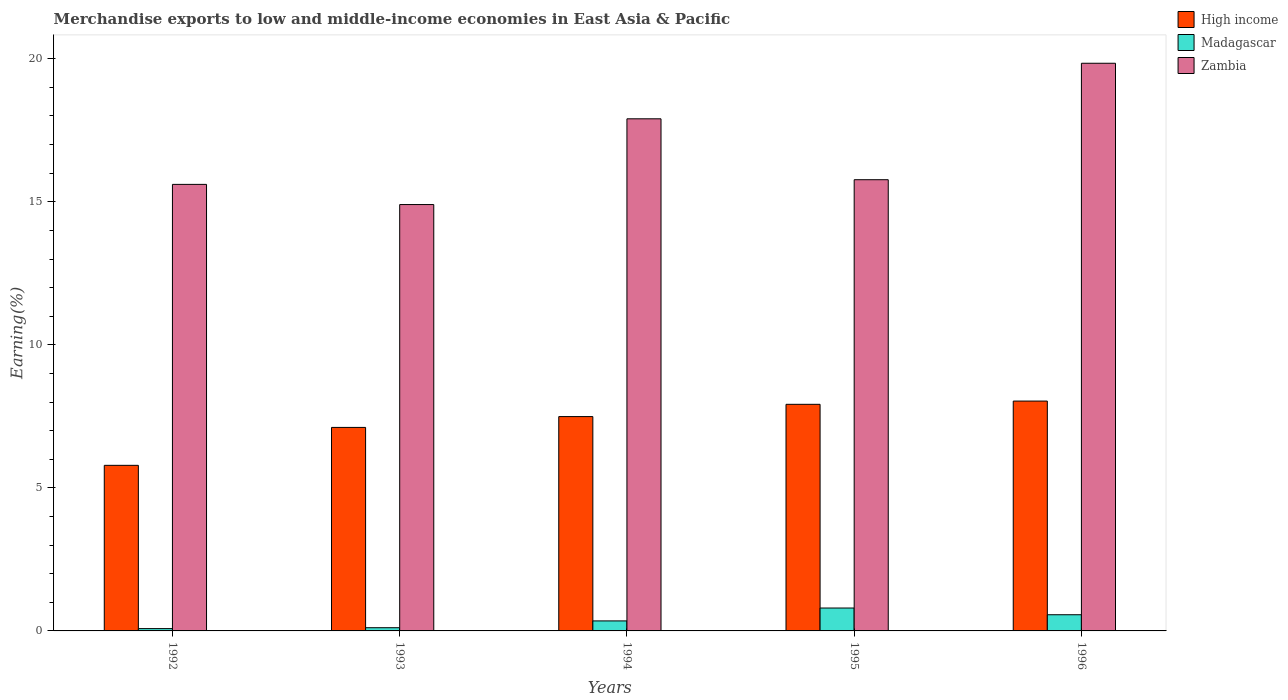How many different coloured bars are there?
Keep it short and to the point. 3. How many groups of bars are there?
Your answer should be very brief. 5. Are the number of bars on each tick of the X-axis equal?
Provide a short and direct response. Yes. How many bars are there on the 1st tick from the right?
Give a very brief answer. 3. What is the label of the 3rd group of bars from the left?
Give a very brief answer. 1994. What is the percentage of amount earned from merchandise exports in High income in 1992?
Make the answer very short. 5.79. Across all years, what is the maximum percentage of amount earned from merchandise exports in Madagascar?
Offer a very short reply. 0.8. Across all years, what is the minimum percentage of amount earned from merchandise exports in Madagascar?
Make the answer very short. 0.08. In which year was the percentage of amount earned from merchandise exports in Zambia minimum?
Provide a short and direct response. 1993. What is the total percentage of amount earned from merchandise exports in Zambia in the graph?
Your response must be concise. 84.03. What is the difference between the percentage of amount earned from merchandise exports in Zambia in 1995 and that in 1996?
Your answer should be very brief. -4.07. What is the difference between the percentage of amount earned from merchandise exports in Zambia in 1996 and the percentage of amount earned from merchandise exports in Madagascar in 1995?
Make the answer very short. 19.04. What is the average percentage of amount earned from merchandise exports in High income per year?
Make the answer very short. 7.27. In the year 1992, what is the difference between the percentage of amount earned from merchandise exports in Zambia and percentage of amount earned from merchandise exports in High income?
Make the answer very short. 9.82. What is the ratio of the percentage of amount earned from merchandise exports in Madagascar in 1993 to that in 1994?
Your response must be concise. 0.32. Is the difference between the percentage of amount earned from merchandise exports in Zambia in 1993 and 1994 greater than the difference between the percentage of amount earned from merchandise exports in High income in 1993 and 1994?
Keep it short and to the point. No. What is the difference between the highest and the second highest percentage of amount earned from merchandise exports in Zambia?
Give a very brief answer. 1.94. What is the difference between the highest and the lowest percentage of amount earned from merchandise exports in Zambia?
Provide a short and direct response. 4.94. In how many years, is the percentage of amount earned from merchandise exports in Zambia greater than the average percentage of amount earned from merchandise exports in Zambia taken over all years?
Offer a terse response. 2. What does the 3rd bar from the left in 1995 represents?
Your answer should be very brief. Zambia. What does the 3rd bar from the right in 1996 represents?
Your answer should be compact. High income. How many bars are there?
Ensure brevity in your answer.  15. How many years are there in the graph?
Offer a terse response. 5. What is the difference between two consecutive major ticks on the Y-axis?
Make the answer very short. 5. Are the values on the major ticks of Y-axis written in scientific E-notation?
Ensure brevity in your answer.  No. Does the graph contain any zero values?
Your answer should be very brief. No. Does the graph contain grids?
Ensure brevity in your answer.  No. Where does the legend appear in the graph?
Make the answer very short. Top right. What is the title of the graph?
Your response must be concise. Merchandise exports to low and middle-income economies in East Asia & Pacific. Does "Peru" appear as one of the legend labels in the graph?
Keep it short and to the point. No. What is the label or title of the X-axis?
Your response must be concise. Years. What is the label or title of the Y-axis?
Ensure brevity in your answer.  Earning(%). What is the Earning(%) in High income in 1992?
Provide a succinct answer. 5.79. What is the Earning(%) of Madagascar in 1992?
Your answer should be very brief. 0.08. What is the Earning(%) of Zambia in 1992?
Offer a very short reply. 15.61. What is the Earning(%) in High income in 1993?
Provide a succinct answer. 7.11. What is the Earning(%) of Madagascar in 1993?
Offer a very short reply. 0.11. What is the Earning(%) of Zambia in 1993?
Your answer should be very brief. 14.9. What is the Earning(%) in High income in 1994?
Ensure brevity in your answer.  7.49. What is the Earning(%) in Madagascar in 1994?
Your answer should be compact. 0.35. What is the Earning(%) of Zambia in 1994?
Your response must be concise. 17.9. What is the Earning(%) in High income in 1995?
Your response must be concise. 7.92. What is the Earning(%) of Madagascar in 1995?
Offer a terse response. 0.8. What is the Earning(%) of Zambia in 1995?
Give a very brief answer. 15.77. What is the Earning(%) in High income in 1996?
Your answer should be compact. 8.03. What is the Earning(%) in Madagascar in 1996?
Give a very brief answer. 0.57. What is the Earning(%) in Zambia in 1996?
Provide a short and direct response. 19.84. Across all years, what is the maximum Earning(%) in High income?
Provide a succinct answer. 8.03. Across all years, what is the maximum Earning(%) of Madagascar?
Provide a succinct answer. 0.8. Across all years, what is the maximum Earning(%) in Zambia?
Keep it short and to the point. 19.84. Across all years, what is the minimum Earning(%) of High income?
Your answer should be compact. 5.79. Across all years, what is the minimum Earning(%) in Madagascar?
Provide a short and direct response. 0.08. Across all years, what is the minimum Earning(%) of Zambia?
Provide a short and direct response. 14.9. What is the total Earning(%) in High income in the graph?
Give a very brief answer. 36.35. What is the total Earning(%) in Madagascar in the graph?
Make the answer very short. 1.91. What is the total Earning(%) in Zambia in the graph?
Your answer should be compact. 84.03. What is the difference between the Earning(%) of High income in 1992 and that in 1993?
Keep it short and to the point. -1.33. What is the difference between the Earning(%) of Madagascar in 1992 and that in 1993?
Keep it short and to the point. -0.03. What is the difference between the Earning(%) in Zambia in 1992 and that in 1993?
Give a very brief answer. 0.71. What is the difference between the Earning(%) of High income in 1992 and that in 1994?
Your answer should be very brief. -1.7. What is the difference between the Earning(%) in Madagascar in 1992 and that in 1994?
Give a very brief answer. -0.27. What is the difference between the Earning(%) of Zambia in 1992 and that in 1994?
Your answer should be very brief. -2.29. What is the difference between the Earning(%) of High income in 1992 and that in 1995?
Keep it short and to the point. -2.13. What is the difference between the Earning(%) of Madagascar in 1992 and that in 1995?
Your response must be concise. -0.72. What is the difference between the Earning(%) in Zambia in 1992 and that in 1995?
Offer a terse response. -0.16. What is the difference between the Earning(%) of High income in 1992 and that in 1996?
Ensure brevity in your answer.  -2.25. What is the difference between the Earning(%) in Madagascar in 1992 and that in 1996?
Offer a very short reply. -0.48. What is the difference between the Earning(%) of Zambia in 1992 and that in 1996?
Your response must be concise. -4.23. What is the difference between the Earning(%) in High income in 1993 and that in 1994?
Make the answer very short. -0.38. What is the difference between the Earning(%) in Madagascar in 1993 and that in 1994?
Provide a succinct answer. -0.24. What is the difference between the Earning(%) in Zambia in 1993 and that in 1994?
Ensure brevity in your answer.  -3. What is the difference between the Earning(%) of High income in 1993 and that in 1995?
Make the answer very short. -0.81. What is the difference between the Earning(%) of Madagascar in 1993 and that in 1995?
Keep it short and to the point. -0.69. What is the difference between the Earning(%) of Zambia in 1993 and that in 1995?
Give a very brief answer. -0.87. What is the difference between the Earning(%) of High income in 1993 and that in 1996?
Ensure brevity in your answer.  -0.92. What is the difference between the Earning(%) in Madagascar in 1993 and that in 1996?
Give a very brief answer. -0.45. What is the difference between the Earning(%) of Zambia in 1993 and that in 1996?
Provide a short and direct response. -4.94. What is the difference between the Earning(%) of High income in 1994 and that in 1995?
Your answer should be very brief. -0.43. What is the difference between the Earning(%) of Madagascar in 1994 and that in 1995?
Make the answer very short. -0.45. What is the difference between the Earning(%) of Zambia in 1994 and that in 1995?
Ensure brevity in your answer.  2.13. What is the difference between the Earning(%) of High income in 1994 and that in 1996?
Your answer should be very brief. -0.54. What is the difference between the Earning(%) in Madagascar in 1994 and that in 1996?
Your answer should be very brief. -0.22. What is the difference between the Earning(%) of Zambia in 1994 and that in 1996?
Make the answer very short. -1.94. What is the difference between the Earning(%) of High income in 1995 and that in 1996?
Your answer should be very brief. -0.11. What is the difference between the Earning(%) of Madagascar in 1995 and that in 1996?
Offer a very short reply. 0.23. What is the difference between the Earning(%) in Zambia in 1995 and that in 1996?
Keep it short and to the point. -4.07. What is the difference between the Earning(%) in High income in 1992 and the Earning(%) in Madagascar in 1993?
Provide a succinct answer. 5.68. What is the difference between the Earning(%) of High income in 1992 and the Earning(%) of Zambia in 1993?
Your response must be concise. -9.12. What is the difference between the Earning(%) of Madagascar in 1992 and the Earning(%) of Zambia in 1993?
Your response must be concise. -14.82. What is the difference between the Earning(%) in High income in 1992 and the Earning(%) in Madagascar in 1994?
Offer a very short reply. 5.44. What is the difference between the Earning(%) of High income in 1992 and the Earning(%) of Zambia in 1994?
Ensure brevity in your answer.  -12.11. What is the difference between the Earning(%) in Madagascar in 1992 and the Earning(%) in Zambia in 1994?
Your response must be concise. -17.82. What is the difference between the Earning(%) in High income in 1992 and the Earning(%) in Madagascar in 1995?
Ensure brevity in your answer.  4.99. What is the difference between the Earning(%) in High income in 1992 and the Earning(%) in Zambia in 1995?
Your answer should be very brief. -9.98. What is the difference between the Earning(%) in Madagascar in 1992 and the Earning(%) in Zambia in 1995?
Your response must be concise. -15.69. What is the difference between the Earning(%) in High income in 1992 and the Earning(%) in Madagascar in 1996?
Your response must be concise. 5.22. What is the difference between the Earning(%) in High income in 1992 and the Earning(%) in Zambia in 1996?
Your answer should be compact. -14.05. What is the difference between the Earning(%) of Madagascar in 1992 and the Earning(%) of Zambia in 1996?
Offer a very short reply. -19.76. What is the difference between the Earning(%) in High income in 1993 and the Earning(%) in Madagascar in 1994?
Make the answer very short. 6.76. What is the difference between the Earning(%) in High income in 1993 and the Earning(%) in Zambia in 1994?
Offer a very short reply. -10.79. What is the difference between the Earning(%) in Madagascar in 1993 and the Earning(%) in Zambia in 1994?
Offer a very short reply. -17.79. What is the difference between the Earning(%) of High income in 1993 and the Earning(%) of Madagascar in 1995?
Offer a very short reply. 6.31. What is the difference between the Earning(%) in High income in 1993 and the Earning(%) in Zambia in 1995?
Your answer should be compact. -8.66. What is the difference between the Earning(%) in Madagascar in 1993 and the Earning(%) in Zambia in 1995?
Offer a terse response. -15.66. What is the difference between the Earning(%) of High income in 1993 and the Earning(%) of Madagascar in 1996?
Provide a short and direct response. 6.55. What is the difference between the Earning(%) in High income in 1993 and the Earning(%) in Zambia in 1996?
Your answer should be compact. -12.73. What is the difference between the Earning(%) of Madagascar in 1993 and the Earning(%) of Zambia in 1996?
Your answer should be compact. -19.73. What is the difference between the Earning(%) in High income in 1994 and the Earning(%) in Madagascar in 1995?
Keep it short and to the point. 6.69. What is the difference between the Earning(%) in High income in 1994 and the Earning(%) in Zambia in 1995?
Keep it short and to the point. -8.28. What is the difference between the Earning(%) in Madagascar in 1994 and the Earning(%) in Zambia in 1995?
Your response must be concise. -15.42. What is the difference between the Earning(%) in High income in 1994 and the Earning(%) in Madagascar in 1996?
Provide a short and direct response. 6.93. What is the difference between the Earning(%) in High income in 1994 and the Earning(%) in Zambia in 1996?
Ensure brevity in your answer.  -12.35. What is the difference between the Earning(%) of Madagascar in 1994 and the Earning(%) of Zambia in 1996?
Ensure brevity in your answer.  -19.49. What is the difference between the Earning(%) of High income in 1995 and the Earning(%) of Madagascar in 1996?
Keep it short and to the point. 7.36. What is the difference between the Earning(%) in High income in 1995 and the Earning(%) in Zambia in 1996?
Offer a very short reply. -11.92. What is the difference between the Earning(%) in Madagascar in 1995 and the Earning(%) in Zambia in 1996?
Make the answer very short. -19.04. What is the average Earning(%) in High income per year?
Your answer should be compact. 7.27. What is the average Earning(%) in Madagascar per year?
Your response must be concise. 0.38. What is the average Earning(%) of Zambia per year?
Your response must be concise. 16.81. In the year 1992, what is the difference between the Earning(%) of High income and Earning(%) of Madagascar?
Offer a terse response. 5.71. In the year 1992, what is the difference between the Earning(%) of High income and Earning(%) of Zambia?
Your answer should be compact. -9.82. In the year 1992, what is the difference between the Earning(%) in Madagascar and Earning(%) in Zambia?
Your answer should be very brief. -15.53. In the year 1993, what is the difference between the Earning(%) of High income and Earning(%) of Madagascar?
Your response must be concise. 7. In the year 1993, what is the difference between the Earning(%) of High income and Earning(%) of Zambia?
Ensure brevity in your answer.  -7.79. In the year 1993, what is the difference between the Earning(%) of Madagascar and Earning(%) of Zambia?
Provide a short and direct response. -14.79. In the year 1994, what is the difference between the Earning(%) in High income and Earning(%) in Madagascar?
Your answer should be compact. 7.14. In the year 1994, what is the difference between the Earning(%) in High income and Earning(%) in Zambia?
Make the answer very short. -10.41. In the year 1994, what is the difference between the Earning(%) in Madagascar and Earning(%) in Zambia?
Keep it short and to the point. -17.55. In the year 1995, what is the difference between the Earning(%) in High income and Earning(%) in Madagascar?
Provide a short and direct response. 7.12. In the year 1995, what is the difference between the Earning(%) in High income and Earning(%) in Zambia?
Make the answer very short. -7.85. In the year 1995, what is the difference between the Earning(%) of Madagascar and Earning(%) of Zambia?
Keep it short and to the point. -14.97. In the year 1996, what is the difference between the Earning(%) of High income and Earning(%) of Madagascar?
Offer a very short reply. 7.47. In the year 1996, what is the difference between the Earning(%) in High income and Earning(%) in Zambia?
Make the answer very short. -11.81. In the year 1996, what is the difference between the Earning(%) in Madagascar and Earning(%) in Zambia?
Offer a terse response. -19.28. What is the ratio of the Earning(%) of High income in 1992 to that in 1993?
Provide a short and direct response. 0.81. What is the ratio of the Earning(%) of Madagascar in 1992 to that in 1993?
Provide a succinct answer. 0.72. What is the ratio of the Earning(%) of Zambia in 1992 to that in 1993?
Your response must be concise. 1.05. What is the ratio of the Earning(%) of High income in 1992 to that in 1994?
Offer a very short reply. 0.77. What is the ratio of the Earning(%) of Madagascar in 1992 to that in 1994?
Your response must be concise. 0.23. What is the ratio of the Earning(%) of Zambia in 1992 to that in 1994?
Give a very brief answer. 0.87. What is the ratio of the Earning(%) in High income in 1992 to that in 1995?
Keep it short and to the point. 0.73. What is the ratio of the Earning(%) in Madagascar in 1992 to that in 1995?
Offer a very short reply. 0.1. What is the ratio of the Earning(%) of Zambia in 1992 to that in 1995?
Give a very brief answer. 0.99. What is the ratio of the Earning(%) in High income in 1992 to that in 1996?
Keep it short and to the point. 0.72. What is the ratio of the Earning(%) of Madagascar in 1992 to that in 1996?
Offer a very short reply. 0.14. What is the ratio of the Earning(%) in Zambia in 1992 to that in 1996?
Provide a short and direct response. 0.79. What is the ratio of the Earning(%) in High income in 1993 to that in 1994?
Provide a succinct answer. 0.95. What is the ratio of the Earning(%) of Madagascar in 1993 to that in 1994?
Your answer should be very brief. 0.32. What is the ratio of the Earning(%) of Zambia in 1993 to that in 1994?
Give a very brief answer. 0.83. What is the ratio of the Earning(%) in High income in 1993 to that in 1995?
Your answer should be compact. 0.9. What is the ratio of the Earning(%) of Madagascar in 1993 to that in 1995?
Your response must be concise. 0.14. What is the ratio of the Earning(%) of Zambia in 1993 to that in 1995?
Provide a short and direct response. 0.94. What is the ratio of the Earning(%) in High income in 1993 to that in 1996?
Keep it short and to the point. 0.89. What is the ratio of the Earning(%) in Madagascar in 1993 to that in 1996?
Make the answer very short. 0.2. What is the ratio of the Earning(%) of Zambia in 1993 to that in 1996?
Provide a succinct answer. 0.75. What is the ratio of the Earning(%) of High income in 1994 to that in 1995?
Keep it short and to the point. 0.95. What is the ratio of the Earning(%) in Madagascar in 1994 to that in 1995?
Give a very brief answer. 0.44. What is the ratio of the Earning(%) of Zambia in 1994 to that in 1995?
Keep it short and to the point. 1.14. What is the ratio of the Earning(%) of High income in 1994 to that in 1996?
Your answer should be compact. 0.93. What is the ratio of the Earning(%) of Madagascar in 1994 to that in 1996?
Keep it short and to the point. 0.62. What is the ratio of the Earning(%) in Zambia in 1994 to that in 1996?
Make the answer very short. 0.9. What is the ratio of the Earning(%) in High income in 1995 to that in 1996?
Keep it short and to the point. 0.99. What is the ratio of the Earning(%) of Madagascar in 1995 to that in 1996?
Make the answer very short. 1.41. What is the ratio of the Earning(%) in Zambia in 1995 to that in 1996?
Your answer should be compact. 0.79. What is the difference between the highest and the second highest Earning(%) of High income?
Provide a short and direct response. 0.11. What is the difference between the highest and the second highest Earning(%) in Madagascar?
Provide a succinct answer. 0.23. What is the difference between the highest and the second highest Earning(%) in Zambia?
Make the answer very short. 1.94. What is the difference between the highest and the lowest Earning(%) of High income?
Your answer should be very brief. 2.25. What is the difference between the highest and the lowest Earning(%) in Madagascar?
Your answer should be very brief. 0.72. What is the difference between the highest and the lowest Earning(%) in Zambia?
Ensure brevity in your answer.  4.94. 